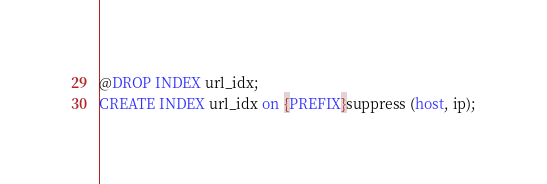<code> <loc_0><loc_0><loc_500><loc_500><_SQL_>@DROP INDEX url_idx;
CREATE INDEX url_idx on {PREFIX}suppress (host, ip);
</code> 